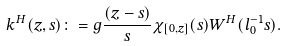<formula> <loc_0><loc_0><loc_500><loc_500>k ^ { H } ( z , s ) \colon = g \frac { ( z - s ) } { s } \chi _ { [ 0 , z ] } ( s ) W ^ { H } ( l _ { 0 } ^ { - 1 } s ) .</formula> 